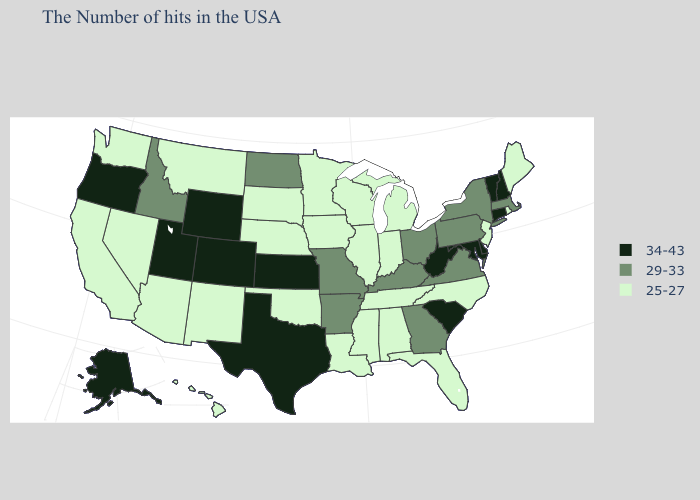What is the value of New Hampshire?
Quick response, please. 34-43. Which states have the lowest value in the South?
Concise answer only. North Carolina, Florida, Alabama, Tennessee, Mississippi, Louisiana, Oklahoma. Does Missouri have a lower value than Tennessee?
Give a very brief answer. No. What is the lowest value in states that border Utah?
Answer briefly. 25-27. What is the lowest value in the USA?
Quick response, please. 25-27. What is the value of Colorado?
Quick response, please. 34-43. What is the value of Georgia?
Write a very short answer. 29-33. Does South Carolina have the highest value in the South?
Be succinct. Yes. What is the value of Arizona?
Keep it brief. 25-27. Which states have the lowest value in the USA?
Quick response, please. Maine, Rhode Island, New Jersey, North Carolina, Florida, Michigan, Indiana, Alabama, Tennessee, Wisconsin, Illinois, Mississippi, Louisiana, Minnesota, Iowa, Nebraska, Oklahoma, South Dakota, New Mexico, Montana, Arizona, Nevada, California, Washington, Hawaii. How many symbols are there in the legend?
Keep it brief. 3. Name the states that have a value in the range 29-33?
Give a very brief answer. Massachusetts, New York, Pennsylvania, Virginia, Ohio, Georgia, Kentucky, Missouri, Arkansas, North Dakota, Idaho. What is the highest value in the MidWest ?
Short answer required. 34-43. Name the states that have a value in the range 25-27?
Concise answer only. Maine, Rhode Island, New Jersey, North Carolina, Florida, Michigan, Indiana, Alabama, Tennessee, Wisconsin, Illinois, Mississippi, Louisiana, Minnesota, Iowa, Nebraska, Oklahoma, South Dakota, New Mexico, Montana, Arizona, Nevada, California, Washington, Hawaii. 